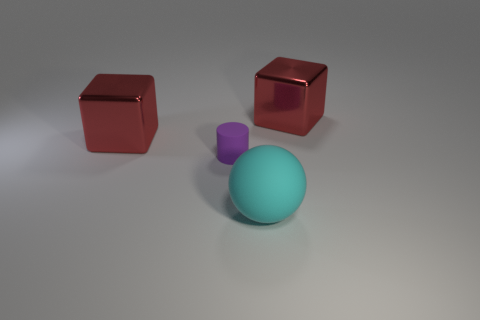Are there the same number of cyan balls in front of the purple rubber object and cyan rubber things that are behind the rubber sphere?
Your answer should be compact. No. How many matte balls are left of the red cube that is behind the large red object that is on the left side of the ball?
Provide a succinct answer. 1. Is the number of big red metallic cubes on the right side of the big cyan thing greater than the number of tiny green cylinders?
Make the answer very short. Yes. How many things are rubber objects in front of the purple rubber thing or objects that are behind the tiny rubber object?
Your answer should be compact. 3. What is the size of the other object that is made of the same material as the purple object?
Offer a terse response. Large. What number of red things are either metal objects or large balls?
Make the answer very short. 2. What number of other things are there of the same shape as the tiny matte object?
Your answer should be compact. 0. There is a object that is on the right side of the small cylinder and behind the large rubber thing; what shape is it?
Ensure brevity in your answer.  Cube. Are there any large cubes on the left side of the large cyan sphere?
Make the answer very short. Yes. Are there any other things that have the same size as the rubber cylinder?
Ensure brevity in your answer.  No. 